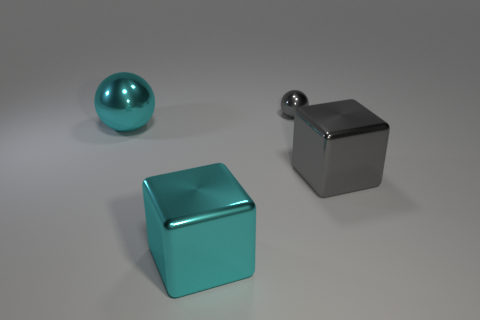Add 1 large yellow cylinders. How many objects exist? 5 Subtract all brown balls. Subtract all blue cylinders. How many balls are left? 2 Subtract all yellow blocks. How many gray spheres are left? 1 Subtract all matte objects. Subtract all large gray shiny objects. How many objects are left? 3 Add 4 gray metallic things. How many gray metallic things are left? 6 Add 4 small green metallic cylinders. How many small green metallic cylinders exist? 4 Subtract 0 yellow cylinders. How many objects are left? 4 